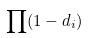<formula> <loc_0><loc_0><loc_500><loc_500>\prod ( 1 - d _ { i } )</formula> 